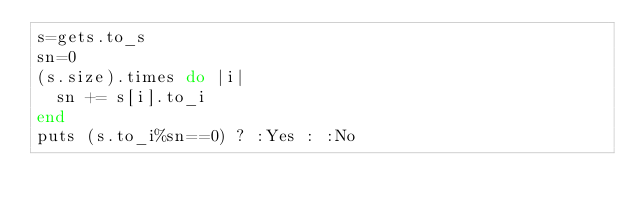Convert code to text. <code><loc_0><loc_0><loc_500><loc_500><_Ruby_>s=gets.to_s
sn=0
(s.size).times do |i|
  sn += s[i].to_i
end
puts (s.to_i%sn==0) ? :Yes : :No</code> 